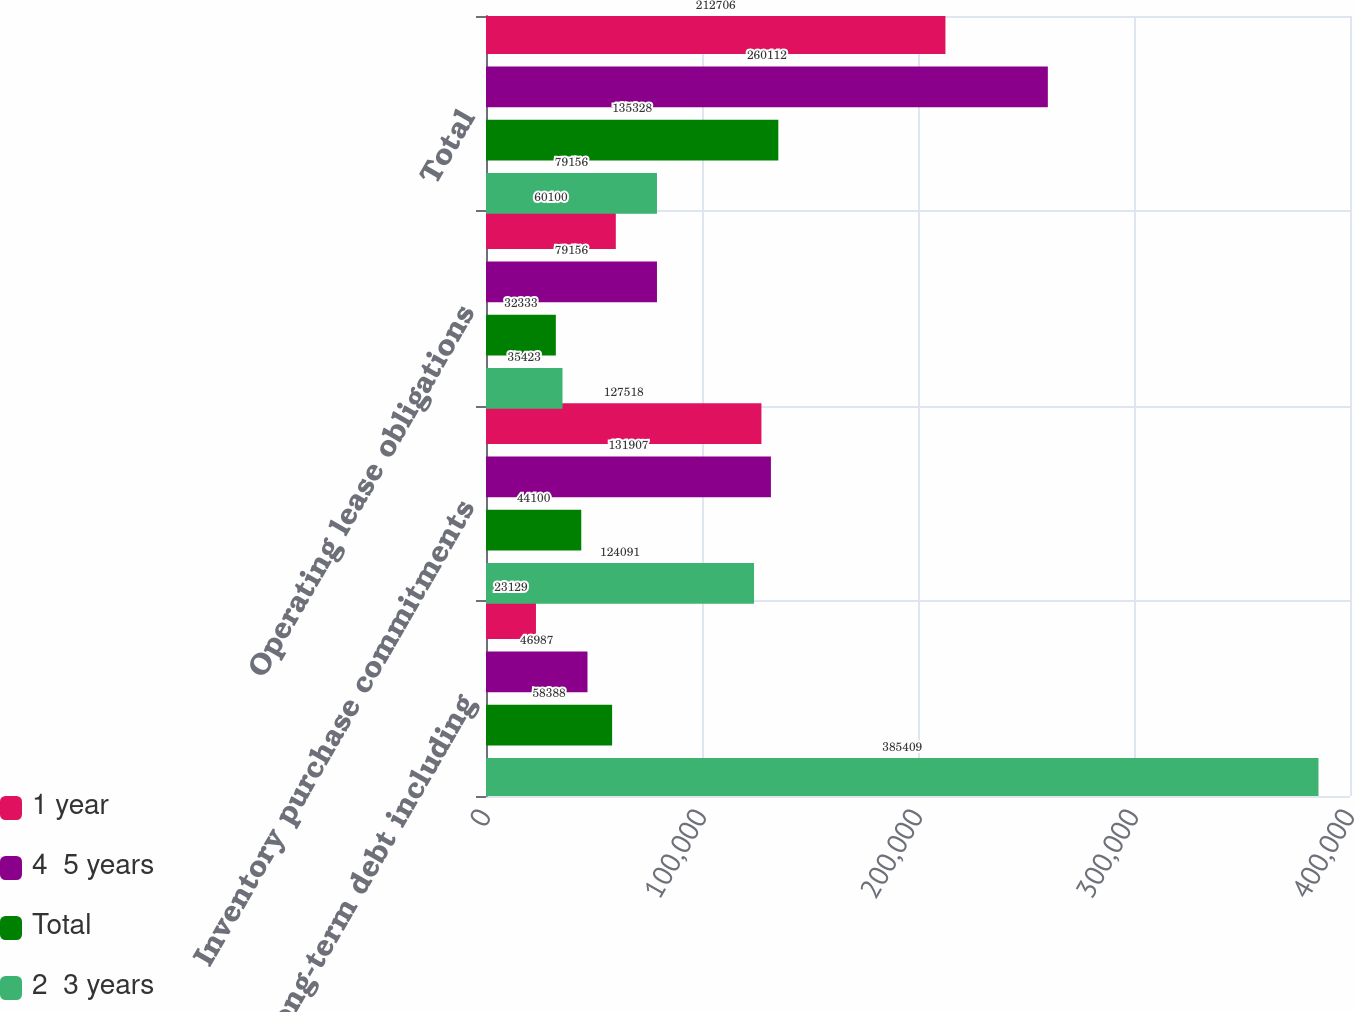Convert chart to OTSL. <chart><loc_0><loc_0><loc_500><loc_500><stacked_bar_chart><ecel><fcel>Long-term debt including<fcel>Inventory purchase commitments<fcel>Operating lease obligations<fcel>Total<nl><fcel>1 year<fcel>23129<fcel>127518<fcel>60100<fcel>212706<nl><fcel>4  5 years<fcel>46987<fcel>131907<fcel>79156<fcel>260112<nl><fcel>Total<fcel>58388<fcel>44100<fcel>32333<fcel>135328<nl><fcel>2  3 years<fcel>385409<fcel>124091<fcel>35423<fcel>79156<nl></chart> 